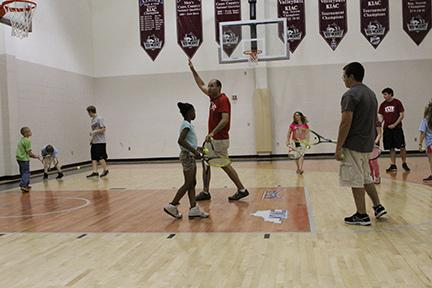Question: what color is the floor?
Choices:
A. Brown.
B. White.
C. Red.
D. Green.
Answer with the letter. Answer: A Question: who are they?
Choices:
A. Players.
B. Parents.
C. Children.
D. Orphans.
Answer with the letter. Answer: A 